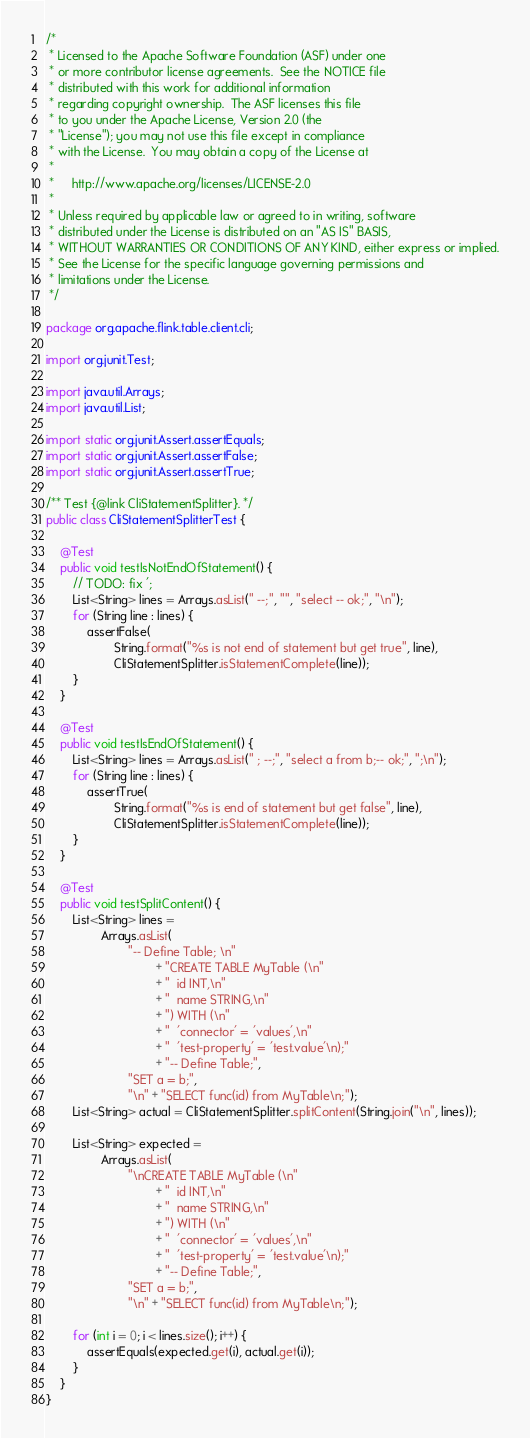Convert code to text. <code><loc_0><loc_0><loc_500><loc_500><_Java_>/*
 * Licensed to the Apache Software Foundation (ASF) under one
 * or more contributor license agreements.  See the NOTICE file
 * distributed with this work for additional information
 * regarding copyright ownership.  The ASF licenses this file
 * to you under the Apache License, Version 2.0 (the
 * "License"); you may not use this file except in compliance
 * with the License.  You may obtain a copy of the License at
 *
 *     http://www.apache.org/licenses/LICENSE-2.0
 *
 * Unless required by applicable law or agreed to in writing, software
 * distributed under the License is distributed on an "AS IS" BASIS,
 * WITHOUT WARRANTIES OR CONDITIONS OF ANY KIND, either express or implied.
 * See the License for the specific language governing permissions and
 * limitations under the License.
 */

package org.apache.flink.table.client.cli;

import org.junit.Test;

import java.util.Arrays;
import java.util.List;

import static org.junit.Assert.assertEquals;
import static org.junit.Assert.assertFalse;
import static org.junit.Assert.assertTrue;

/** Test {@link CliStatementSplitter}. */
public class CliStatementSplitterTest {

    @Test
    public void testIsNotEndOfStatement() {
        // TODO: fix ';
        List<String> lines = Arrays.asList(" --;", "", "select -- ok;", "\n");
        for (String line : lines) {
            assertFalse(
                    String.format("%s is not end of statement but get true", line),
                    CliStatementSplitter.isStatementComplete(line));
        }
    }

    @Test
    public void testIsEndOfStatement() {
        List<String> lines = Arrays.asList(" ; --;", "select a from b;-- ok;", ";\n");
        for (String line : lines) {
            assertTrue(
                    String.format("%s is end of statement but get false", line),
                    CliStatementSplitter.isStatementComplete(line));
        }
    }

    @Test
    public void testSplitContent() {
        List<String> lines =
                Arrays.asList(
                        "-- Define Table; \n"
                                + "CREATE TABLE MyTable (\n"
                                + "  id INT,\n"
                                + "  name STRING,\n"
                                + ") WITH (\n"
                                + "  'connector' = 'values',\n"
                                + "  'test-property' = 'test.value'\n);"
                                + "-- Define Table;",
                        "SET a = b;",
                        "\n" + "SELECT func(id) from MyTable\n;");
        List<String> actual = CliStatementSplitter.splitContent(String.join("\n", lines));

        List<String> expected =
                Arrays.asList(
                        "\nCREATE TABLE MyTable (\n"
                                + "  id INT,\n"
                                + "  name STRING,\n"
                                + ") WITH (\n"
                                + "  'connector' = 'values',\n"
                                + "  'test-property' = 'test.value'\n);"
                                + "-- Define Table;",
                        "SET a = b;",
                        "\n" + "SELECT func(id) from MyTable\n;");

        for (int i = 0; i < lines.size(); i++) {
            assertEquals(expected.get(i), actual.get(i));
        }
    }
}
</code> 